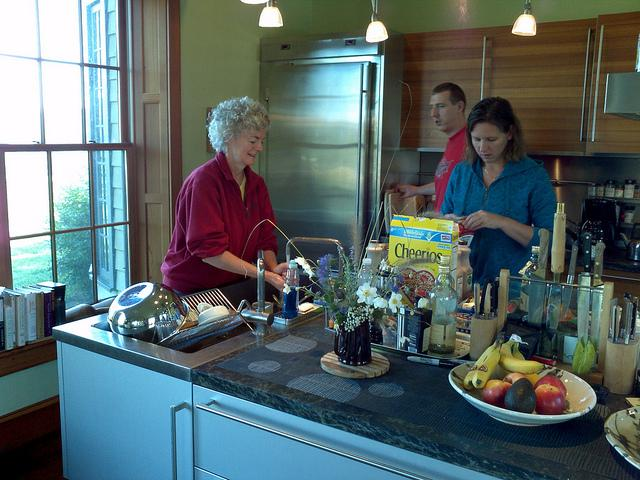What time of day is it?

Choices:
A) night
B) evening
C) morning
D) afternoon morning 